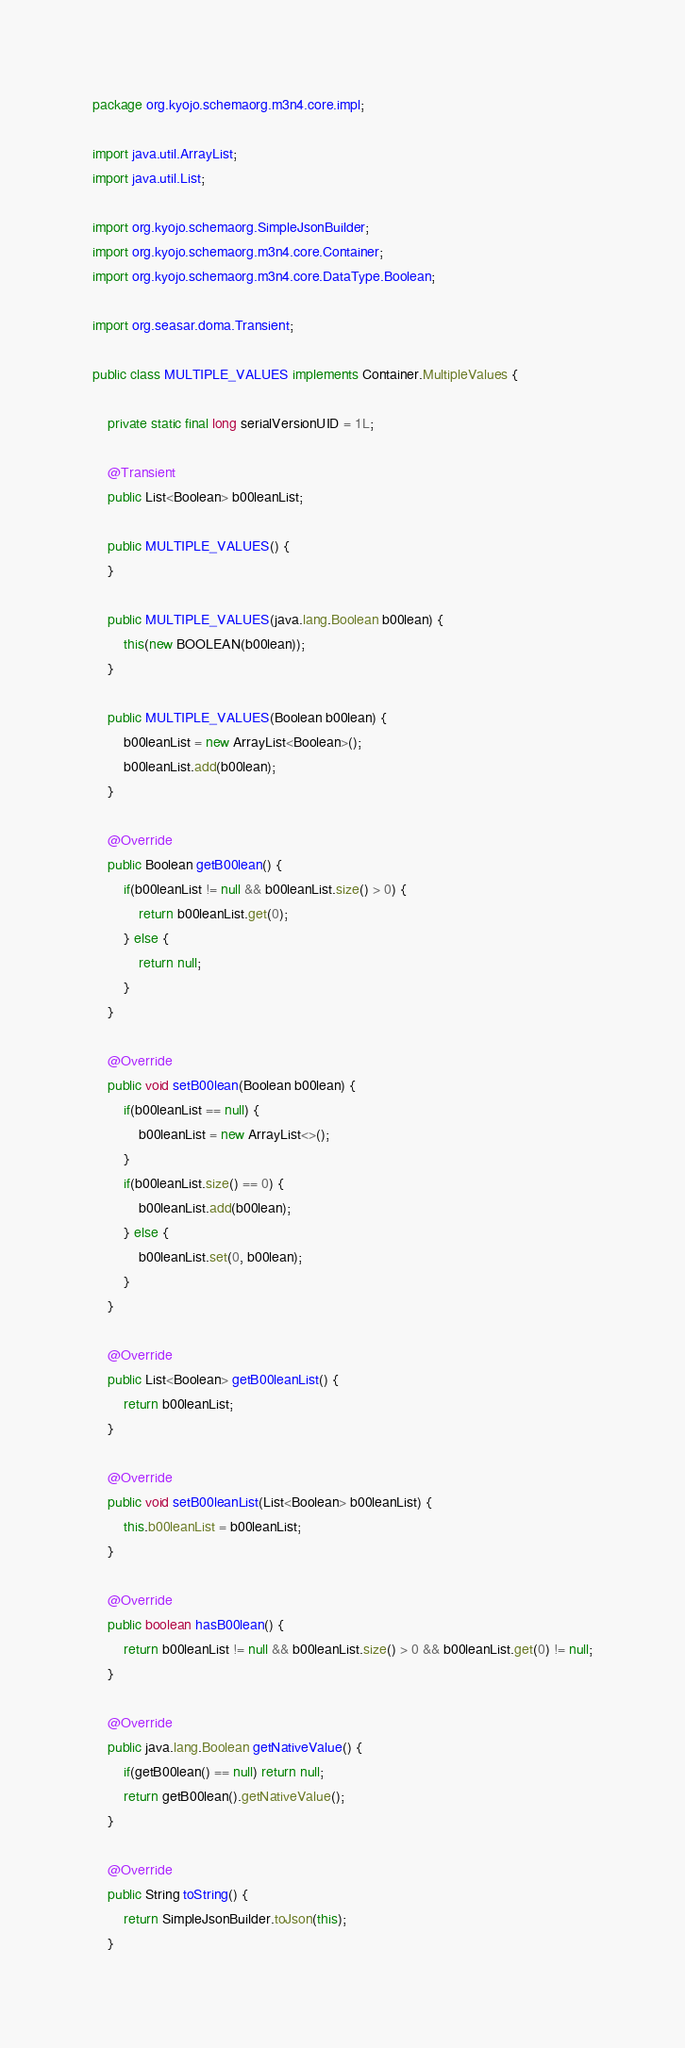Convert code to text. <code><loc_0><loc_0><loc_500><loc_500><_Java_>package org.kyojo.schemaorg.m3n4.core.impl;

import java.util.ArrayList;
import java.util.List;

import org.kyojo.schemaorg.SimpleJsonBuilder;
import org.kyojo.schemaorg.m3n4.core.Container;
import org.kyojo.schemaorg.m3n4.core.DataType.Boolean;

import org.seasar.doma.Transient;

public class MULTIPLE_VALUES implements Container.MultipleValues {

	private static final long serialVersionUID = 1L;

	@Transient
	public List<Boolean> b00leanList;

	public MULTIPLE_VALUES() {
	}

	public MULTIPLE_VALUES(java.lang.Boolean b00lean) {
		this(new BOOLEAN(b00lean));
	}

	public MULTIPLE_VALUES(Boolean b00lean) {
		b00leanList = new ArrayList<Boolean>();
		b00leanList.add(b00lean);
	}

	@Override
	public Boolean getB00lean() {
		if(b00leanList != null && b00leanList.size() > 0) {
			return b00leanList.get(0);
		} else {
			return null;
		}
	}

	@Override
	public void setB00lean(Boolean b00lean) {
		if(b00leanList == null) {
			b00leanList = new ArrayList<>();
		}
		if(b00leanList.size() == 0) {
			b00leanList.add(b00lean);
		} else {
			b00leanList.set(0, b00lean);
		}
	}

	@Override
	public List<Boolean> getB00leanList() {
		return b00leanList;
	}

	@Override
	public void setB00leanList(List<Boolean> b00leanList) {
		this.b00leanList = b00leanList;
	}

	@Override
	public boolean hasB00lean() {
		return b00leanList != null && b00leanList.size() > 0 && b00leanList.get(0) != null;
	}

	@Override
	public java.lang.Boolean getNativeValue() {
		if(getB00lean() == null) return null;
		return getB00lean().getNativeValue();
	}

	@Override
	public String toString() {
		return SimpleJsonBuilder.toJson(this);
	}
</code> 